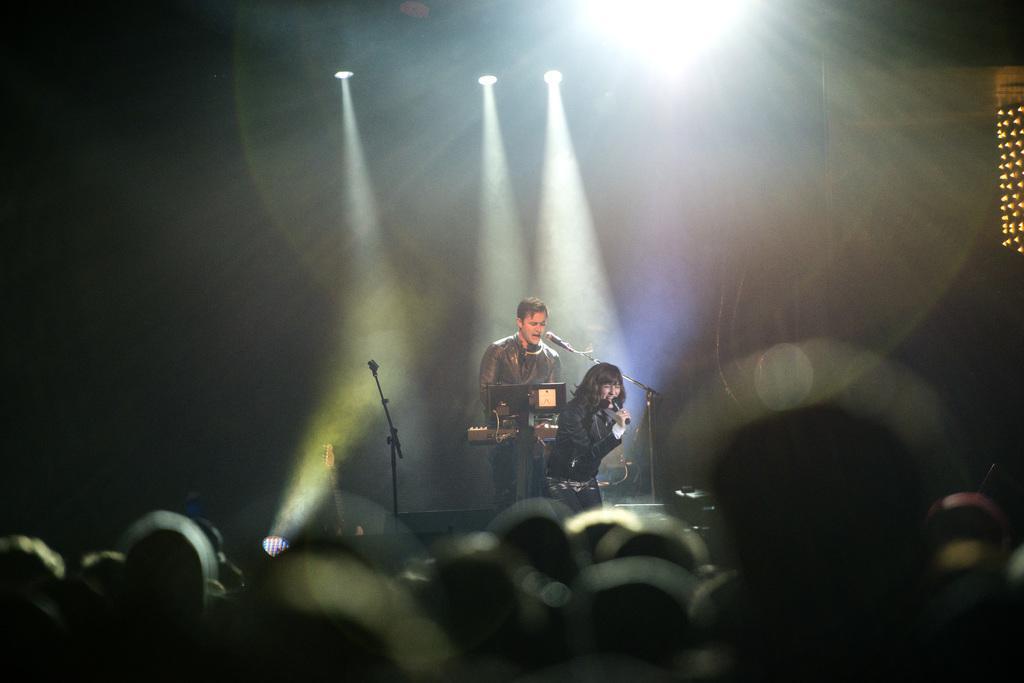In one or two sentences, can you explain what this image depicts? In this image we can see some lights, one microphone stand, one board, one woman standing holding a microphone and singing. There is one guitar, one object looks like a musical instrument in front of the man, one microphone with stand, some people's heads at the bottom of the image, one man standing on the stage and singing. This image is dark and blurred. 